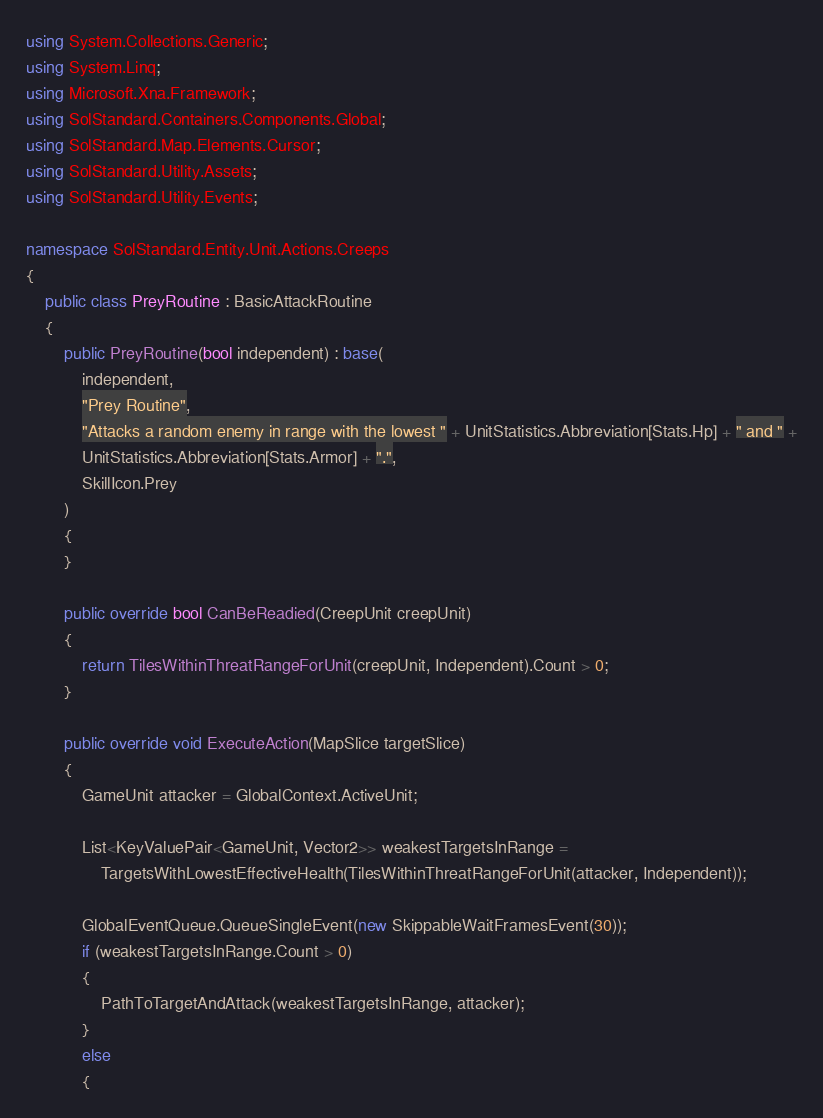Convert code to text. <code><loc_0><loc_0><loc_500><loc_500><_C#_>using System.Collections.Generic;
using System.Linq;
using Microsoft.Xna.Framework;
using SolStandard.Containers.Components.Global;
using SolStandard.Map.Elements.Cursor;
using SolStandard.Utility.Assets;
using SolStandard.Utility.Events;

namespace SolStandard.Entity.Unit.Actions.Creeps
{
    public class PreyRoutine : BasicAttackRoutine
    {
        public PreyRoutine(bool independent) : base(
            independent,
            "Prey Routine",
            "Attacks a random enemy in range with the lowest " + UnitStatistics.Abbreviation[Stats.Hp] + " and " +
            UnitStatistics.Abbreviation[Stats.Armor] + ".",
            SkillIcon.Prey
        )
        {
        }

        public override bool CanBeReadied(CreepUnit creepUnit)
        {
            return TilesWithinThreatRangeForUnit(creepUnit, Independent).Count > 0;
        }

        public override void ExecuteAction(MapSlice targetSlice)
        {
            GameUnit attacker = GlobalContext.ActiveUnit;

            List<KeyValuePair<GameUnit, Vector2>> weakestTargetsInRange =
                TargetsWithLowestEffectiveHealth(TilesWithinThreatRangeForUnit(attacker, Independent));

            GlobalEventQueue.QueueSingleEvent(new SkippableWaitFramesEvent(30));
            if (weakestTargetsInRange.Count > 0)
            {
                PathToTargetAndAttack(weakestTargetsInRange, attacker);
            }
            else
            {</code> 